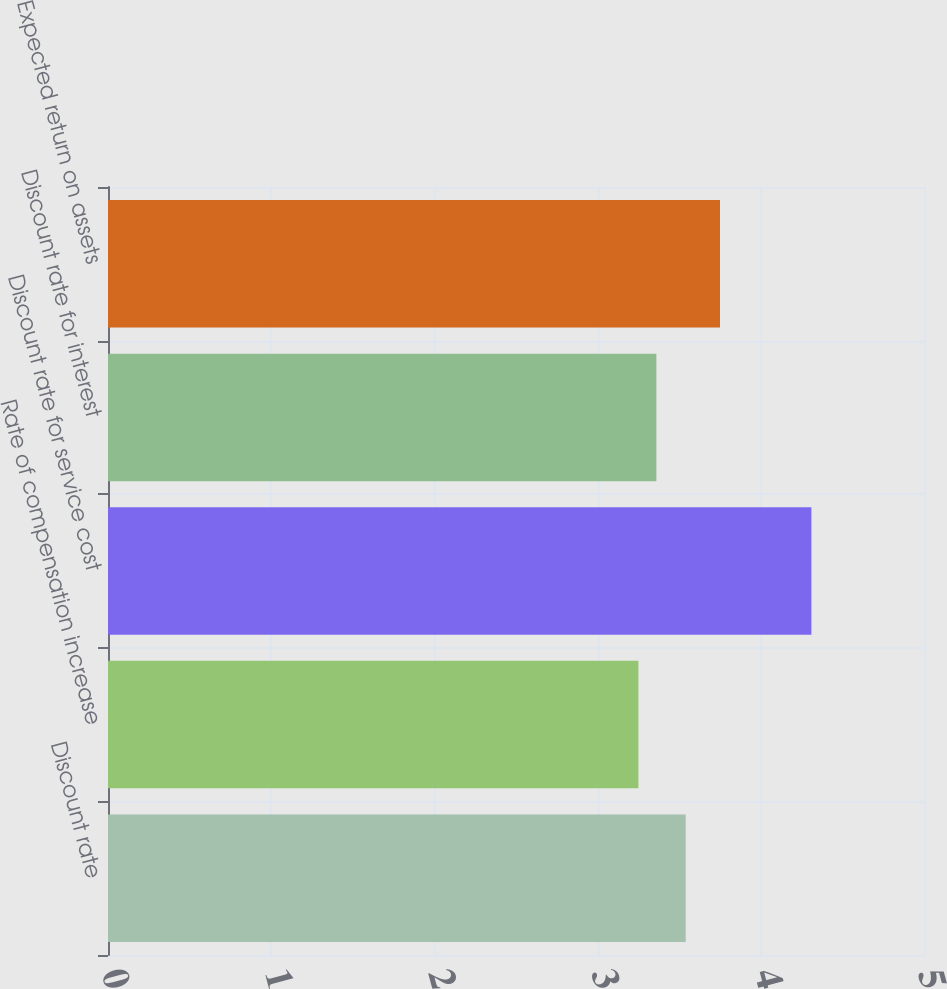<chart> <loc_0><loc_0><loc_500><loc_500><bar_chart><fcel>Discount rate<fcel>Rate of compensation increase<fcel>Discount rate for service cost<fcel>Discount rate for interest<fcel>Expected return on assets<nl><fcel>3.54<fcel>3.25<fcel>4.31<fcel>3.36<fcel>3.75<nl></chart> 